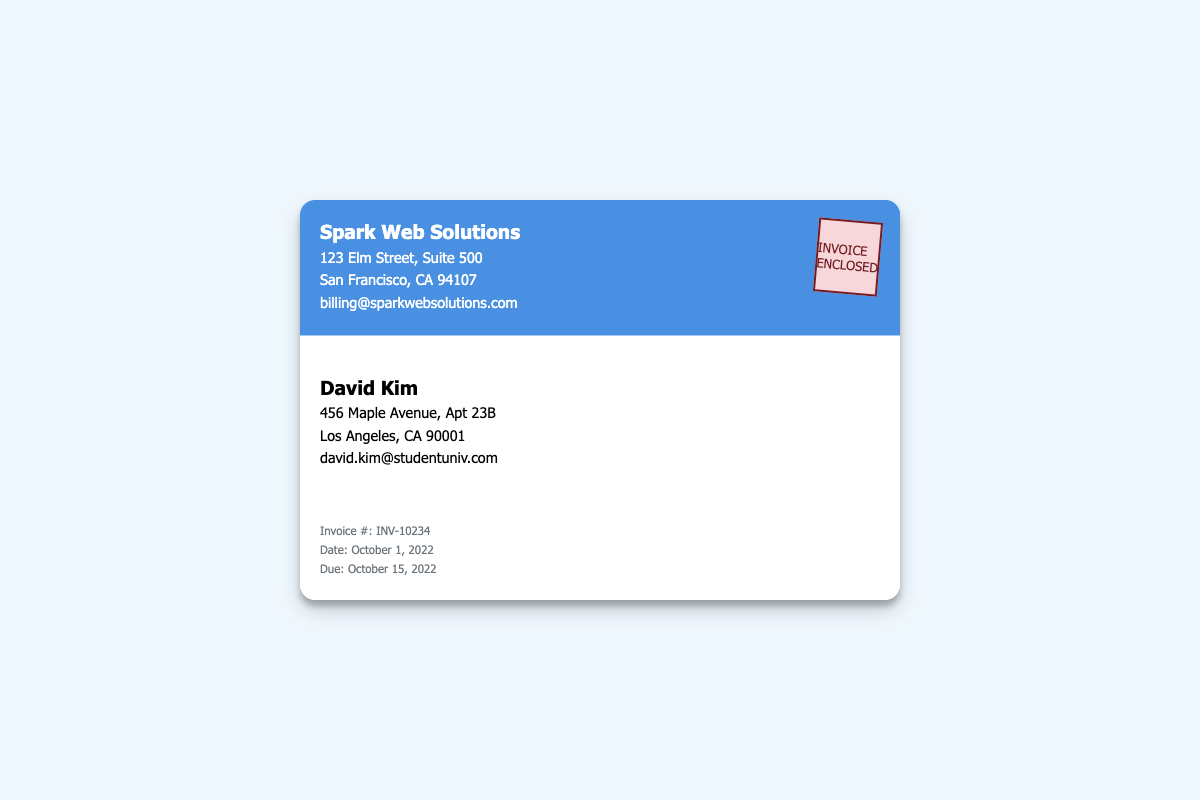What is the sender's name? The sender's name is clearly stated at the top of the envelope as "Spark Web Solutions."
Answer: Spark Web Solutions What is the recipient's address? The recipient's address is listed in the envelope under David Kim's name.
Answer: 456 Maple Avenue, Apt 23B What is the invoice number? The invoice number is mentioned in the invoice details section.
Answer: INV-10234 When is the invoice due? The due date for the invoice is provided in the document under the invoice details.
Answer: October 15, 2022 What color is the sender's section? The sender's section of the envelope is specified to have a background color.
Answer: Blue Who is the recipient of this invoice? The recipient's name appears prominently in the envelope alongside their details.
Answer: David Kim What is the date of the invoice? The date can be found in the invoice details section, indicating when the invoice was issued.
Answer: October 1, 2022 What type of document is this? The type of document is indicated in the stamp located on the envelope.
Answer: Invoice What is included with the invoice? The stamp provides clarity on the contents of the envelope.
Answer: Invoice Enclosed 